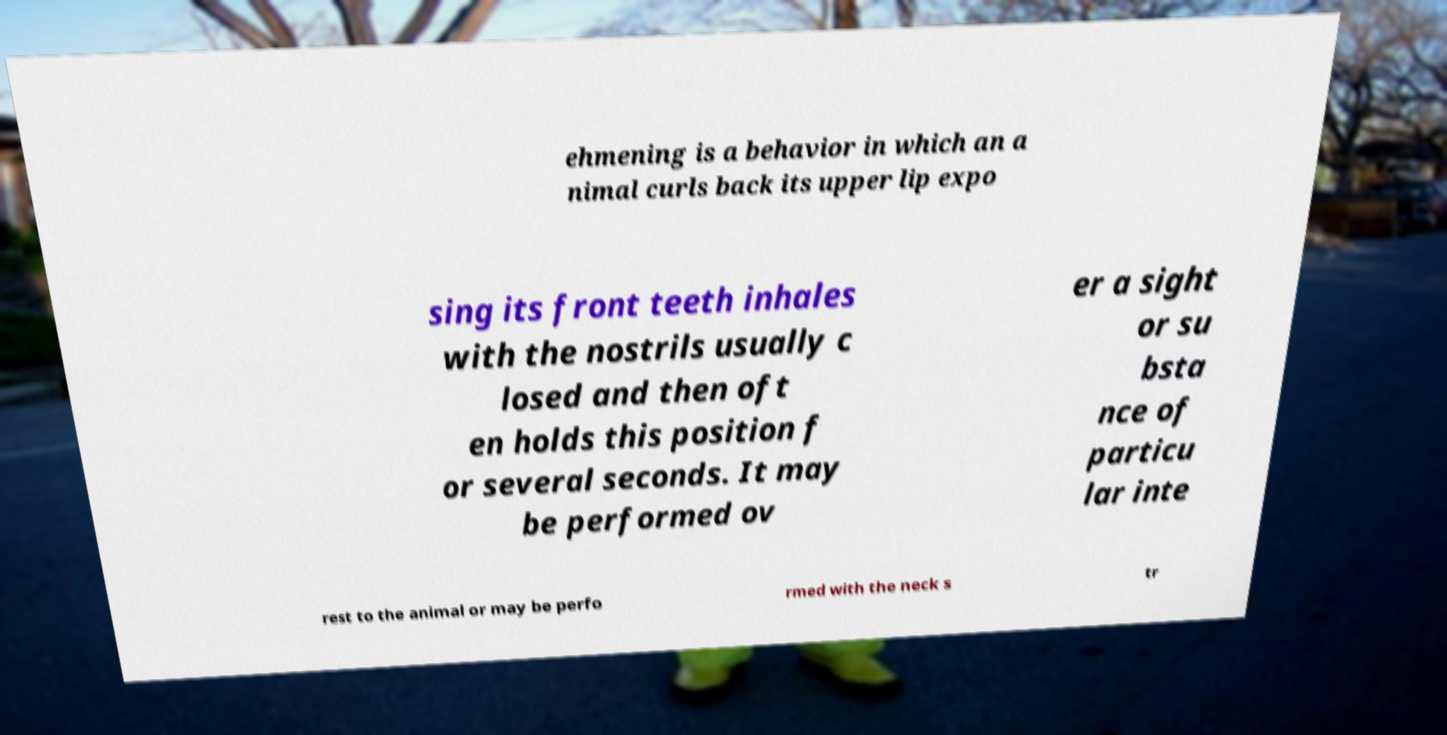For documentation purposes, I need the text within this image transcribed. Could you provide that? ehmening is a behavior in which an a nimal curls back its upper lip expo sing its front teeth inhales with the nostrils usually c losed and then oft en holds this position f or several seconds. It may be performed ov er a sight or su bsta nce of particu lar inte rest to the animal or may be perfo rmed with the neck s tr 